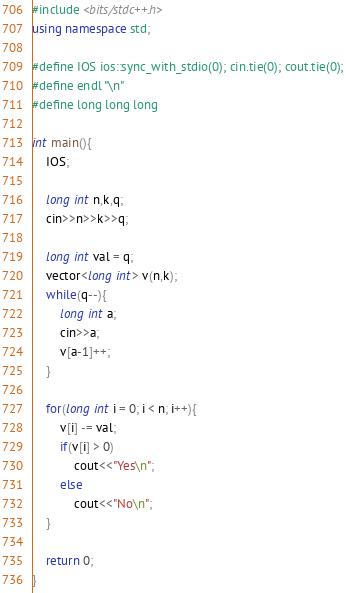<code> <loc_0><loc_0><loc_500><loc_500><_C++_>#include <bits/stdc++.h>
using namespace std;

#define IOS ios::sync_with_stdio(0); cin.tie(0); cout.tie(0);
#define endl "\n"
#define long long long

int main(){
    IOS;

    long int n,k,q;
    cin>>n>>k>>q;

	long int val = q;
    vector<long int> v(n,k);
    while(q--){
        long int a;
        cin>>a;
        v[a-1]++;
    }

    for(long int i = 0; i < n; i++){
        v[i] -= val;
        if(v[i] > 0)
            cout<<"Yes\n";
        else
            cout<<"No\n";
    }

    return 0;
}</code> 